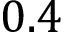<formula> <loc_0><loc_0><loc_500><loc_500>0 . 4</formula> 